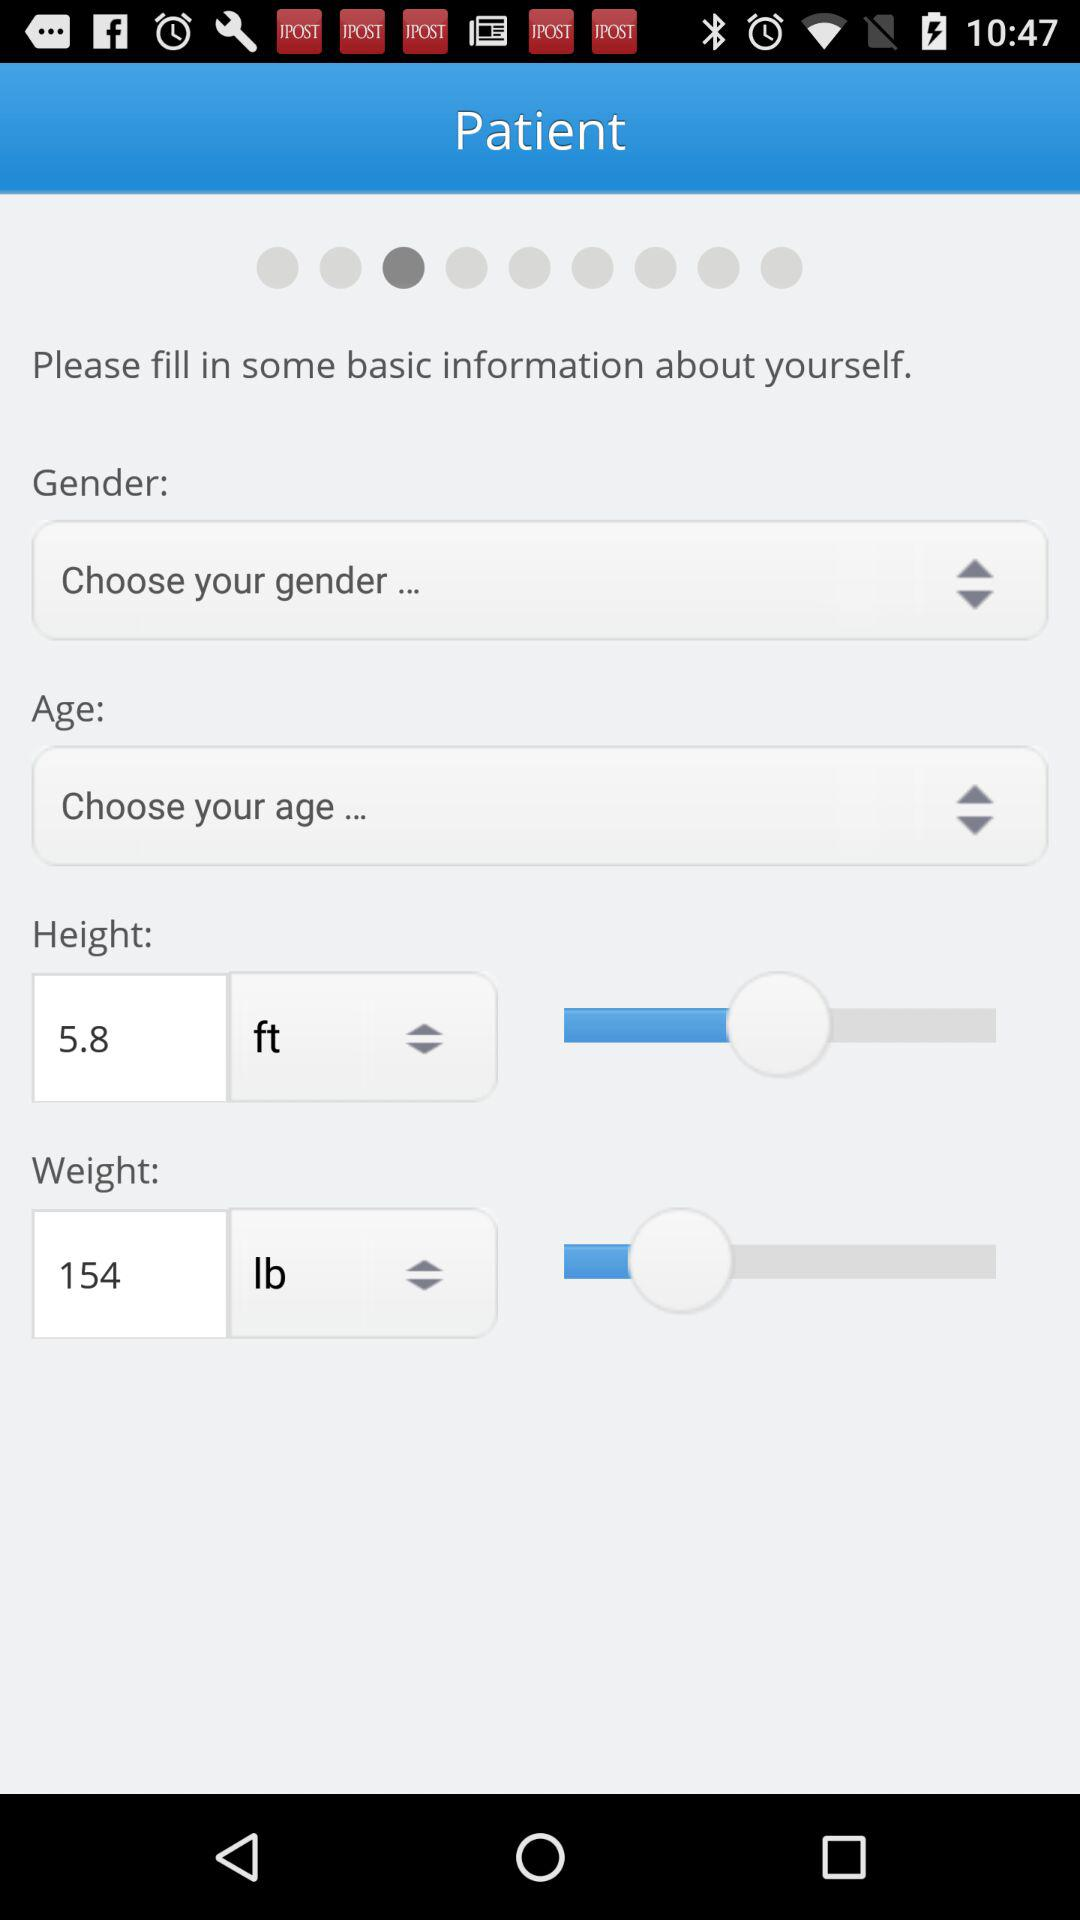What is the patient height? The patient's height is 5.8 feet. 